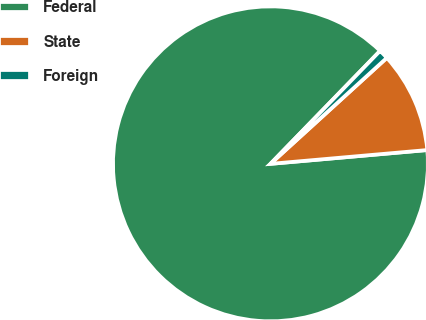<chart> <loc_0><loc_0><loc_500><loc_500><pie_chart><fcel>Federal<fcel>State<fcel>Foreign<nl><fcel>88.65%<fcel>10.36%<fcel>0.98%<nl></chart> 